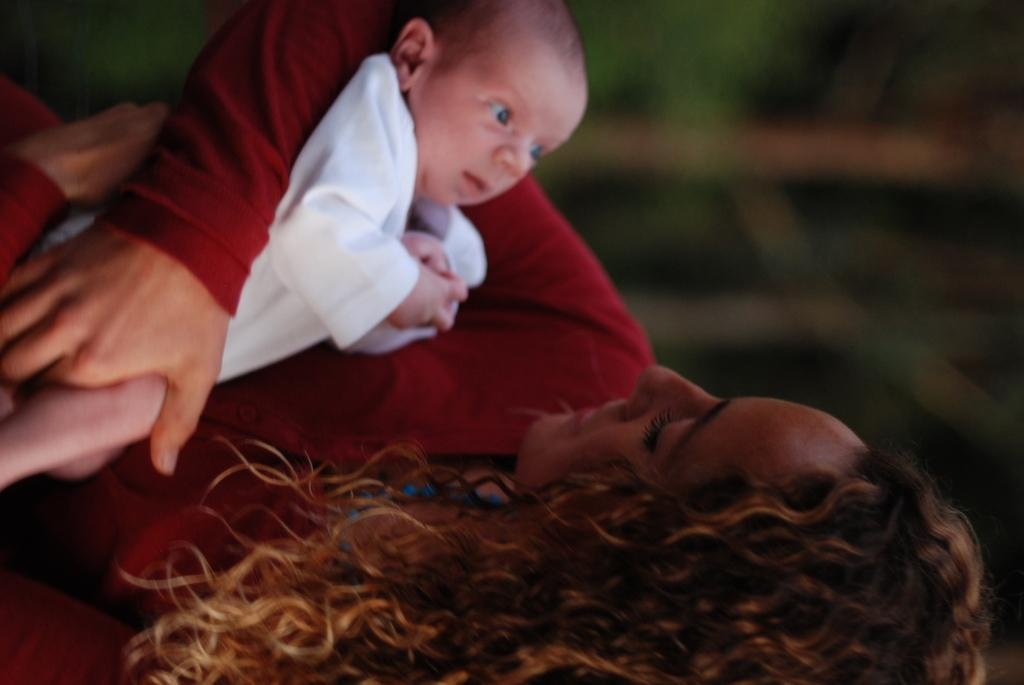Who is the main subject in the image? There is a woman in the image. What is the woman doing in the image? The woman is holding a child. What is the woman wearing in the image? The woman is wearing a red dress. What is the child wearing in the image? The child is wearing a white dress. What can be said about the woman's hair in the image? The woman has curly hair, and it is brown in color. What type of ornament is hanging from the woman's collar in the image? There is no ornament hanging from the woman's collar in the image, as she is not wearing a collar. 